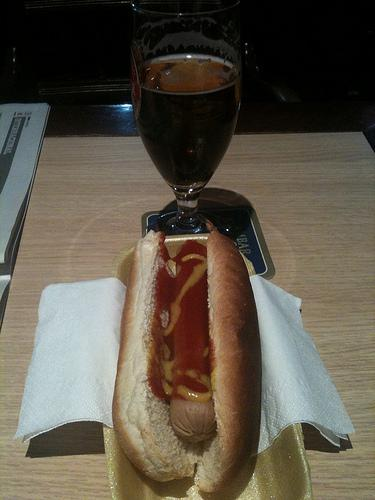Question: where was this photo taken?
Choices:
A. In the building.
B. By the car.
C. In a restaurant.
D. With friends.
Answer with the letter. Answer: C Question: what is present?
Choices:
A. Gifts.
B. Drinks.
C. Dishes.
D. Food.
Answer with the letter. Answer: D 